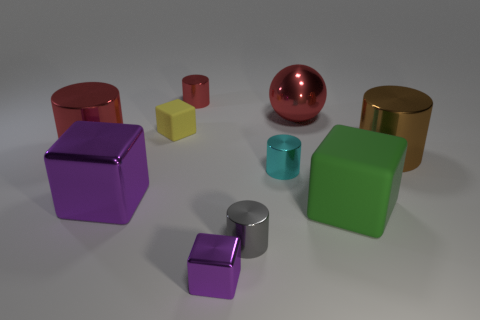How might the different sizes of these objects be significant? The varying sizes of the objects might indicate their functional diversity or simply an aesthetic arrangement. Larger objects could serve as storage containers or display pieces, while smaller ones might be intended for individual use, like a paperweight or ornamental accent.  Can you describe the lighting and shadows in the scene? The lighting in the scene is soft and diffused, casting gentle shadows that subtly indicate the form and texture of each object. The light seems to be coming from a direction that is not directly overhead, creating a calm atmosphere and enhancing the three-dimensionality of the objects. 